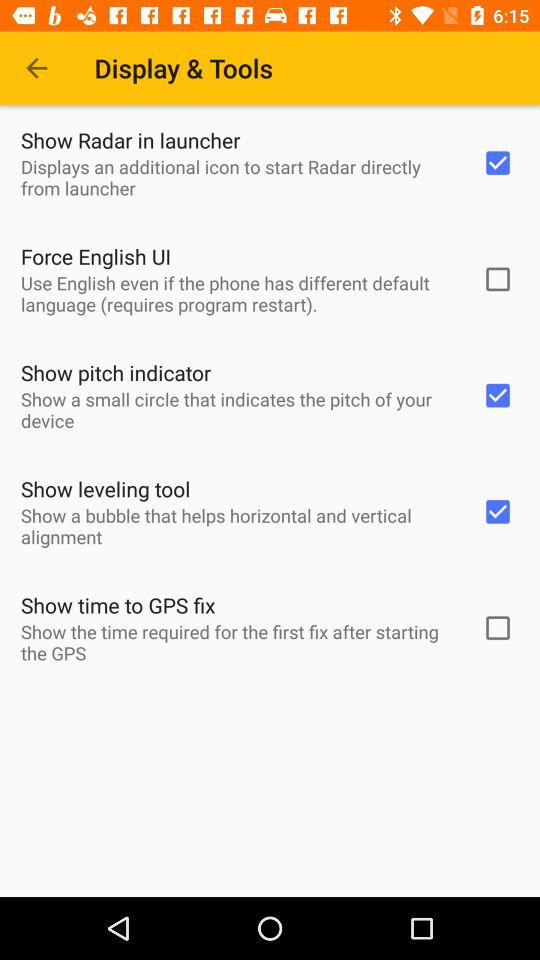What is the status of "Force English UI"? The status is off. 